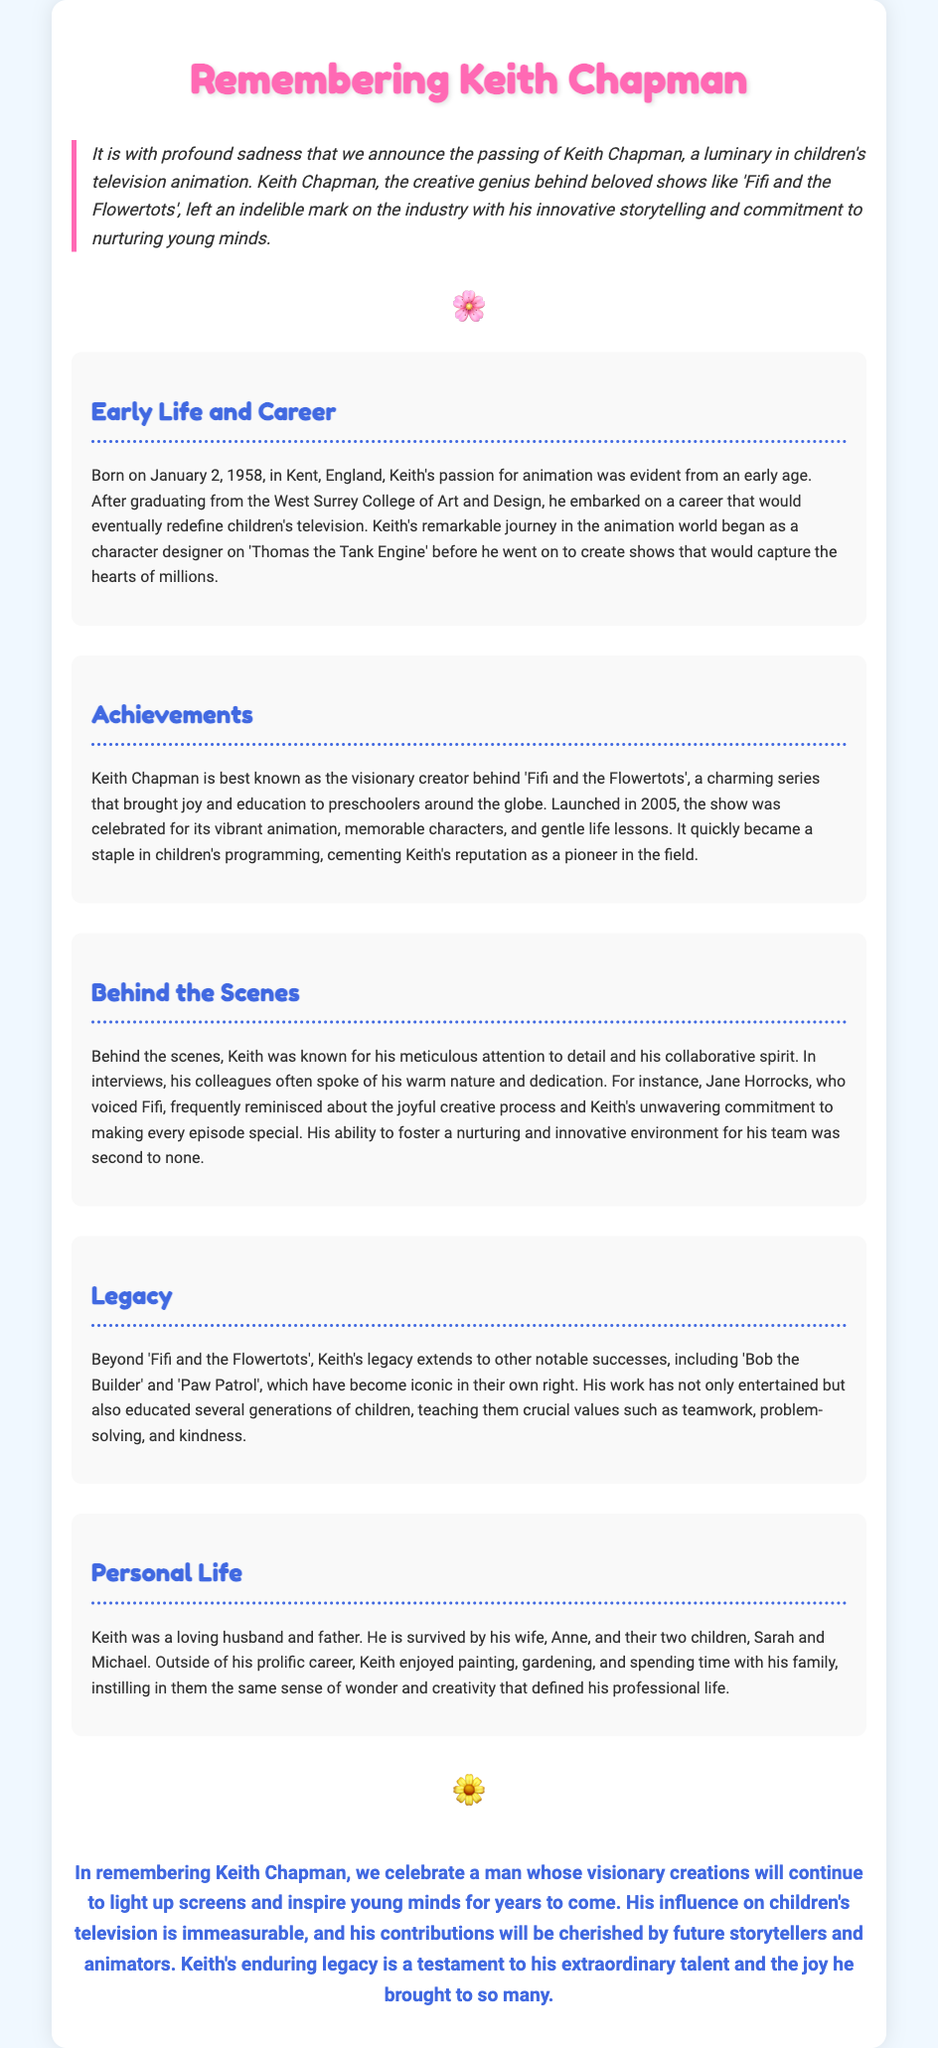what was the full name of the animation director? The document states the director's full name as Keith Chapman.
Answer: Keith Chapman what year was 'Fifi and the Flowertots' launched? The document mentions that 'Fifi and the Flowertots' was launched in 2005.
Answer: 2005 how many children did Keith Chapman have? The document indicates that Keith is survived by two children.
Answer: two which character did Jane Horrocks voice? The document notes that Jane Horrocks voiced Fifi.
Answer: Fifi what did Keith Chapman enjoy doing outside of his career? The document lists painting, gardening, and spending time with family as activities Keith enjoyed.
Answer: painting, gardening, and spending time with family what does Keith's work primarily teach children? The document states that his work teaches crucial values such as teamwork, problem-solving, and kindness.
Answer: teamwork, problem-solving, and kindness how is Keith’s attention to detail described in the document? The document describes Keith's attention to detail as meticulous.
Answer: meticulous what year was Keith Chapman born? The document specifies that Keith was born on January 2, 1958.
Answer: January 2, 1958 